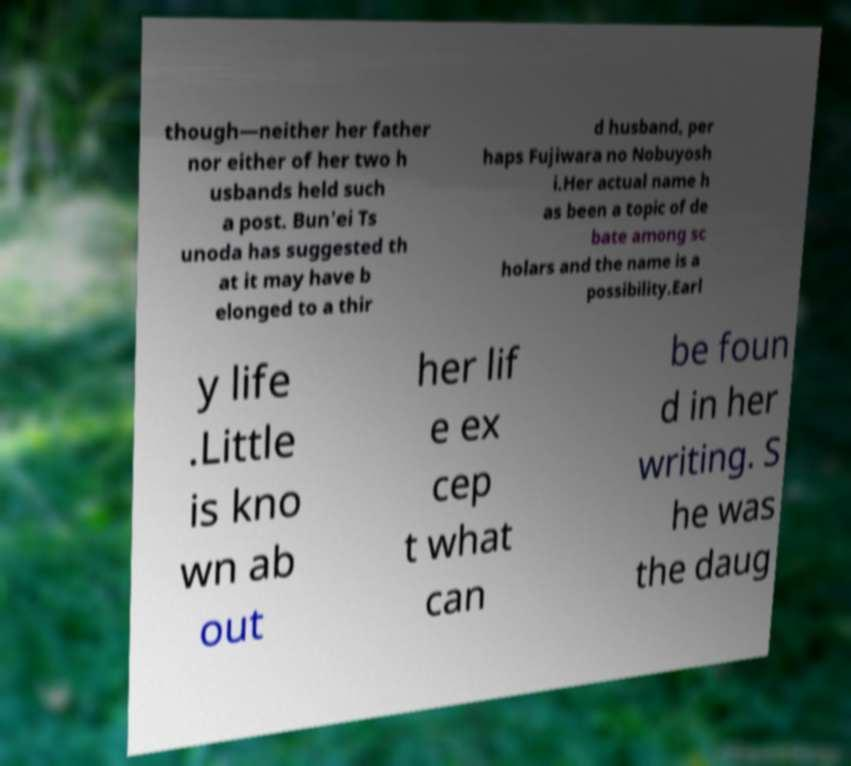Could you extract and type out the text from this image? though—neither her father nor either of her two h usbands held such a post. Bun'ei Ts unoda has suggested th at it may have b elonged to a thir d husband, per haps Fujiwara no Nobuyosh i.Her actual name h as been a topic of de bate among sc holars and the name is a possibility.Earl y life .Little is kno wn ab out her lif e ex cep t what can be foun d in her writing. S he was the daug 